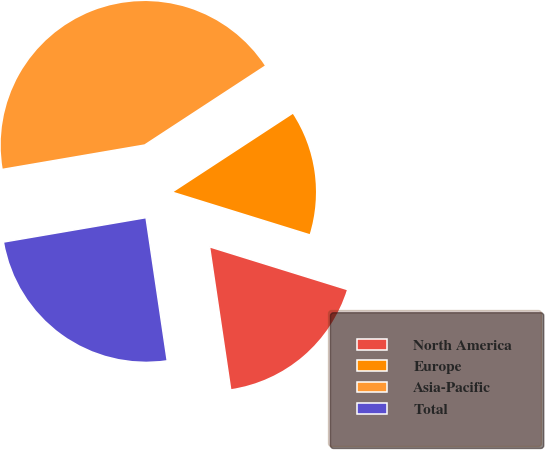Convert chart. <chart><loc_0><loc_0><loc_500><loc_500><pie_chart><fcel>North America<fcel>Europe<fcel>Asia-Pacific<fcel>Total<nl><fcel>17.87%<fcel>14.01%<fcel>43.48%<fcel>24.64%<nl></chart> 